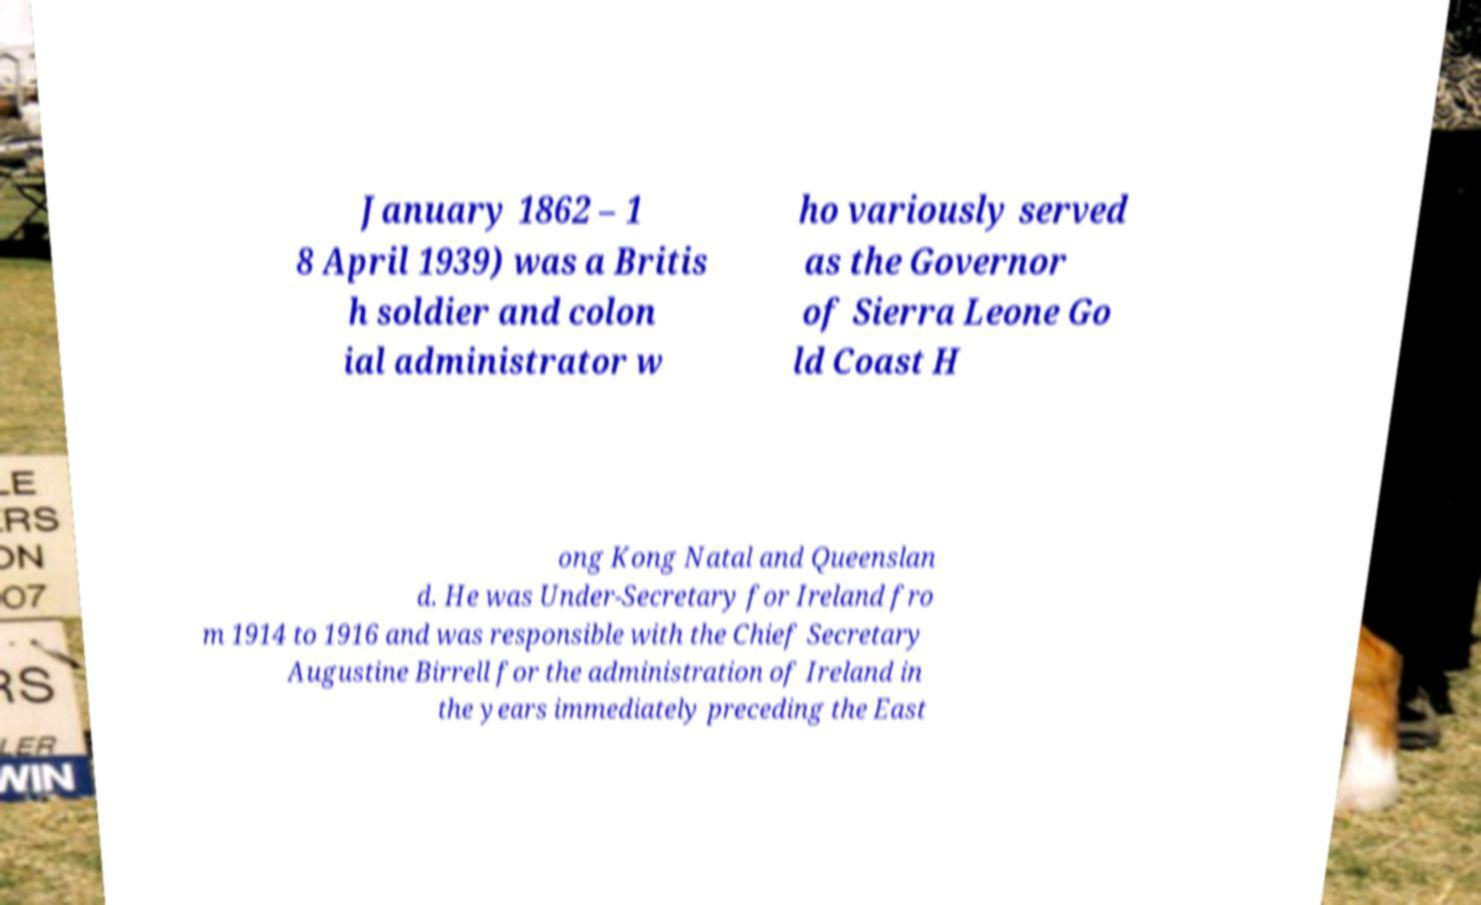What messages or text are displayed in this image? I need them in a readable, typed format. January 1862 – 1 8 April 1939) was a Britis h soldier and colon ial administrator w ho variously served as the Governor of Sierra Leone Go ld Coast H ong Kong Natal and Queenslan d. He was Under-Secretary for Ireland fro m 1914 to 1916 and was responsible with the Chief Secretary Augustine Birrell for the administration of Ireland in the years immediately preceding the East 